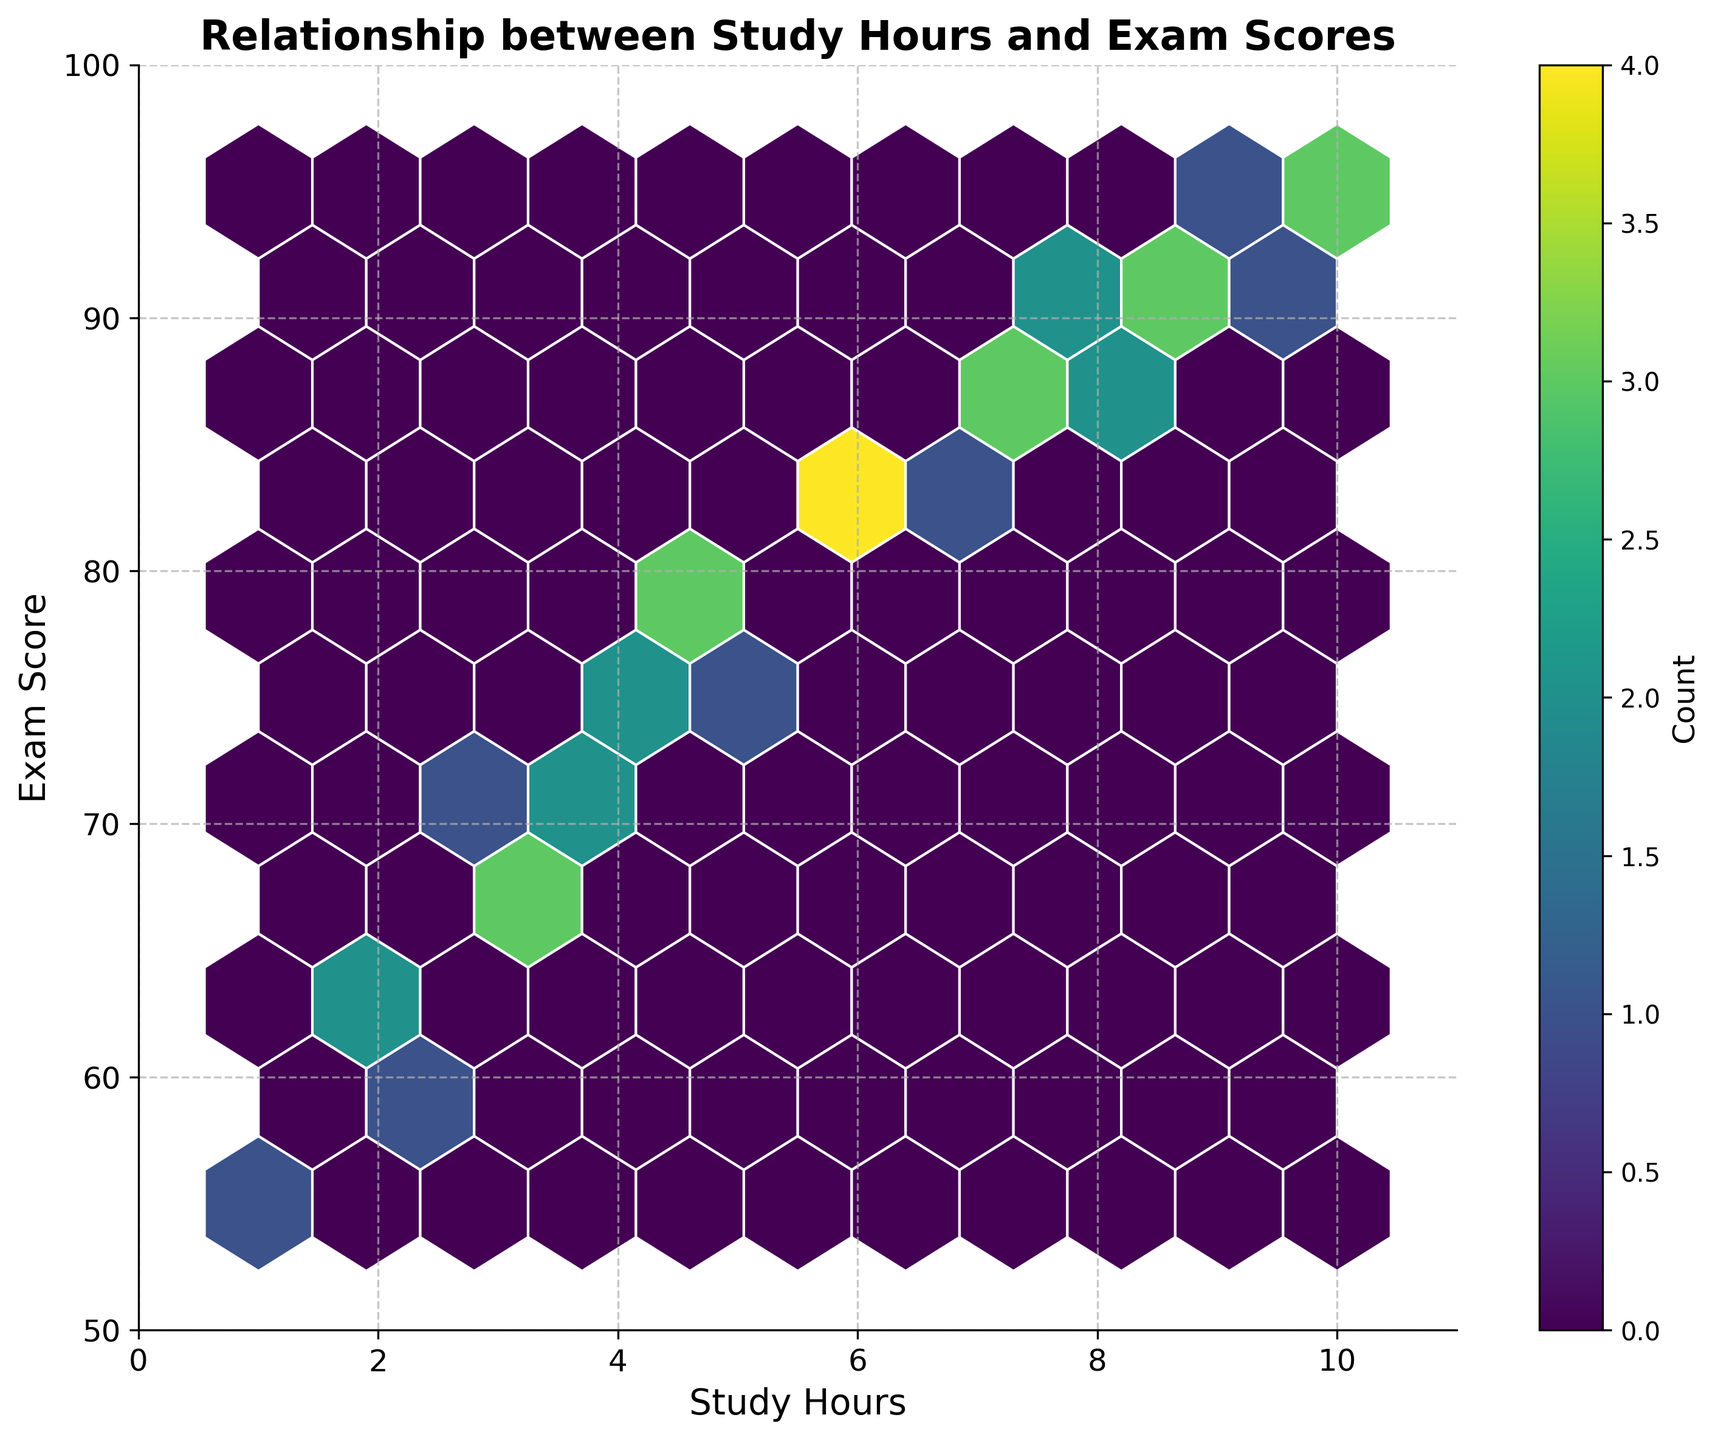What's the title of the figure? The title is located at the top of the figure and is typically larger in font size and bold. It states the purpose of the plot.
Answer: Relationship between Study Hours and Exam Scores What is the color scheme used in the hexbin plot? The color scheme can be identified by examining the surfaces of the hexagons, where the colormap represents different counts of data points per hexagon.
Answer: Viridis What range does the x-axis cover? The x-axis, labeled "Study Hours," is inspected by looking at its start and end values. These integers denote the range covered.
Answer: 0 to 11 Which area on the plot indicates the highest concentration of data points? The colorbar shows that darker colors represent higher counts. By locating the darkest hexagons, we can find the area with the highest concentration.
Answer: Around 7 to 10 study hours and 85 to 95 exam scores How many data points appear to fall within the 6 to 7 study hours range? By looking at the hexagons between the 6 and 7 values on the x-axis, and checking the color intensity and values, the count can be inferred.
Answer: Approximately 8 to 12 Compare the distribution of exam scores for study hours between 5 and 6 and those between 9 and 10. Which range shows higher variability? Observe the spread of hexagons and colors between the given ranges of study hours. Higher variability is indicated by a wider spread in y-values (exam scores).
Answer: 5 to 6 study hours range What is the count value of the hexagon located at approximately 9 study hours and 93 exam score? Check the color of the hexagon at this coordinate and match it to the colorbar to determine the count.
Answer: 2 What can you infer about the overall relationship between study hours and exam scores? By analyzing the trend of hexagons from lower left to upper right, determine if there is a visible correlation.
Answer: Positive correlation How does the count change as one moves from the bottom hexagon to the top hexagon on the plot? Follow the path from the lower hexagons to the upper hexagons while observing the changes in color, which denote changes in count.
Answer: Counts generally decrease What might be a reason that the hexagon density varies substantially across the plot? Reflect on the implications of different study habits and academic performance, leading to non-uniform data point distribution.
Answer: Different student study behaviors and performance levels 